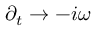<formula> <loc_0><loc_0><loc_500><loc_500>\partial _ { t } \to - i \omega</formula> 